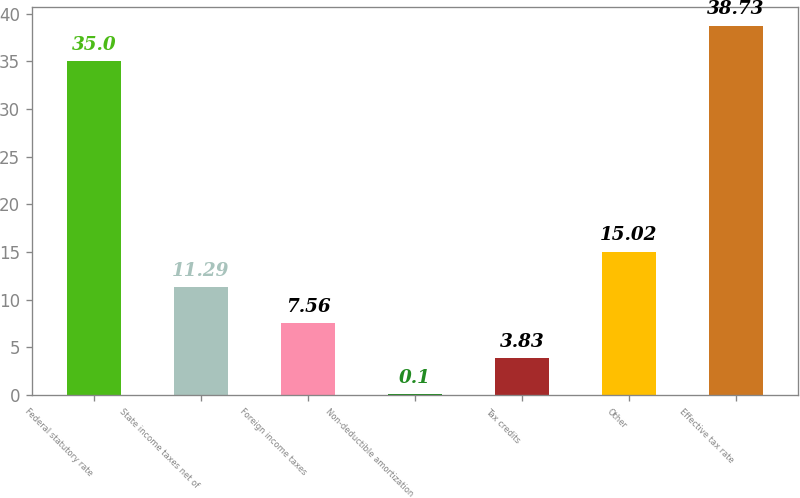Convert chart. <chart><loc_0><loc_0><loc_500><loc_500><bar_chart><fcel>Federal statutory rate<fcel>State income taxes net of<fcel>Foreign income taxes<fcel>Non-deductible amortization<fcel>Tax credits<fcel>Other<fcel>Effective tax rate<nl><fcel>35<fcel>11.29<fcel>7.56<fcel>0.1<fcel>3.83<fcel>15.02<fcel>38.73<nl></chart> 